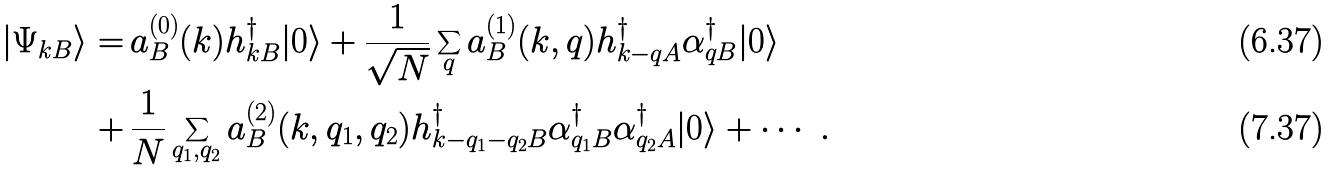Convert formula to latex. <formula><loc_0><loc_0><loc_500><loc_500>| \Psi _ { { k } B } \rangle = & \, a ^ { ( 0 ) } _ { B } ( { k } ) h ^ { \dag } _ { { k } B } | 0 \rangle + \frac { 1 } { \sqrt { N } } \sum _ { q } a ^ { ( 1 ) } _ { B } ( { k } , { q } ) h ^ { \dag } _ { { k } - { q } A } \alpha _ { { q } B } ^ { \dag } | 0 \rangle \\ + & \, \frac { 1 } { N } \sum _ { { q } _ { 1 } , { q } _ { 2 } } a ^ { ( 2 ) } _ { B } ( { k } , { q } _ { 1 } , { q } _ { 2 } ) h ^ { \dag } _ { { k } - { q } _ { 1 } - { q } _ { 2 } B } \alpha _ { { q } _ { 1 } B } ^ { \dag } \alpha _ { { q } _ { 2 } A } ^ { \dag } | 0 \rangle + \cdots \ .</formula> 